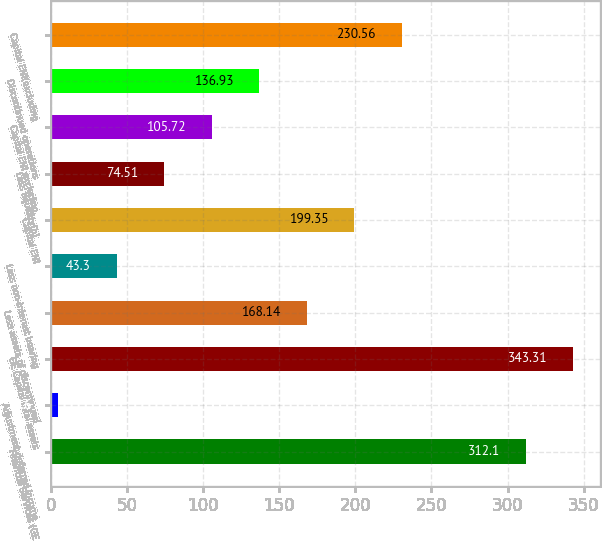<chart> <loc_0><loc_0><loc_500><loc_500><bar_chart><fcel>Financial Services (GE<fcel>Adjustment deferred income<fcel>GE Capital total assets<fcel>Less assets of discontinued<fcel>Less non-interest bearing<fcel>Capital ENI<fcel>Less liquidity(b)<fcel>Capital ENI excluding<fcel>Discontinued operations<fcel>Capital ENI(excluding<nl><fcel>312.1<fcel>4.6<fcel>343.31<fcel>168.14<fcel>43.3<fcel>199.35<fcel>74.51<fcel>105.72<fcel>136.93<fcel>230.56<nl></chart> 